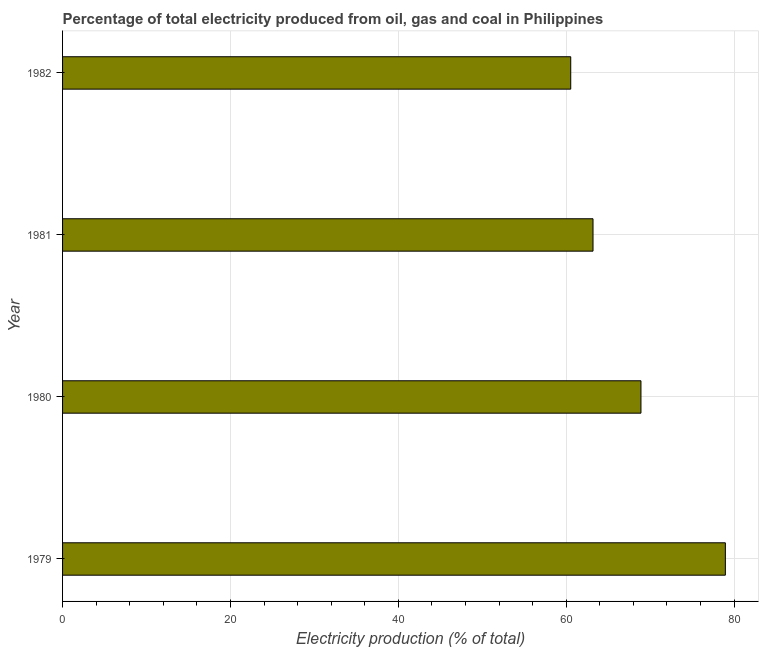Does the graph contain any zero values?
Make the answer very short. No. What is the title of the graph?
Your answer should be compact. Percentage of total electricity produced from oil, gas and coal in Philippines. What is the label or title of the X-axis?
Your answer should be compact. Electricity production (% of total). What is the electricity production in 1980?
Your response must be concise. 68.91. Across all years, what is the maximum electricity production?
Give a very brief answer. 78.97. Across all years, what is the minimum electricity production?
Your answer should be compact. 60.54. In which year was the electricity production maximum?
Provide a short and direct response. 1979. In which year was the electricity production minimum?
Give a very brief answer. 1982. What is the sum of the electricity production?
Provide a short and direct response. 271.62. What is the difference between the electricity production in 1980 and 1982?
Ensure brevity in your answer.  8.37. What is the average electricity production per year?
Provide a succinct answer. 67.9. What is the median electricity production?
Your response must be concise. 66.05. What is the ratio of the electricity production in 1981 to that in 1982?
Make the answer very short. 1.04. Is the difference between the electricity production in 1980 and 1981 greater than the difference between any two years?
Make the answer very short. No. What is the difference between the highest and the second highest electricity production?
Ensure brevity in your answer.  10.05. What is the difference between the highest and the lowest electricity production?
Provide a succinct answer. 18.42. In how many years, is the electricity production greater than the average electricity production taken over all years?
Provide a succinct answer. 2. Are all the bars in the graph horizontal?
Provide a succinct answer. Yes. What is the difference between two consecutive major ticks on the X-axis?
Your response must be concise. 20. What is the Electricity production (% of total) in 1979?
Your answer should be very brief. 78.97. What is the Electricity production (% of total) in 1980?
Keep it short and to the point. 68.91. What is the Electricity production (% of total) in 1981?
Your answer should be compact. 63.2. What is the Electricity production (% of total) in 1982?
Your response must be concise. 60.54. What is the difference between the Electricity production (% of total) in 1979 and 1980?
Ensure brevity in your answer.  10.06. What is the difference between the Electricity production (% of total) in 1979 and 1981?
Offer a terse response. 15.77. What is the difference between the Electricity production (% of total) in 1979 and 1982?
Provide a short and direct response. 18.42. What is the difference between the Electricity production (% of total) in 1980 and 1981?
Offer a terse response. 5.71. What is the difference between the Electricity production (% of total) in 1980 and 1982?
Make the answer very short. 8.37. What is the difference between the Electricity production (% of total) in 1981 and 1982?
Keep it short and to the point. 2.65. What is the ratio of the Electricity production (% of total) in 1979 to that in 1980?
Ensure brevity in your answer.  1.15. What is the ratio of the Electricity production (% of total) in 1979 to that in 1981?
Your answer should be compact. 1.25. What is the ratio of the Electricity production (% of total) in 1979 to that in 1982?
Make the answer very short. 1.3. What is the ratio of the Electricity production (% of total) in 1980 to that in 1981?
Give a very brief answer. 1.09. What is the ratio of the Electricity production (% of total) in 1980 to that in 1982?
Give a very brief answer. 1.14. What is the ratio of the Electricity production (% of total) in 1981 to that in 1982?
Ensure brevity in your answer.  1.04. 